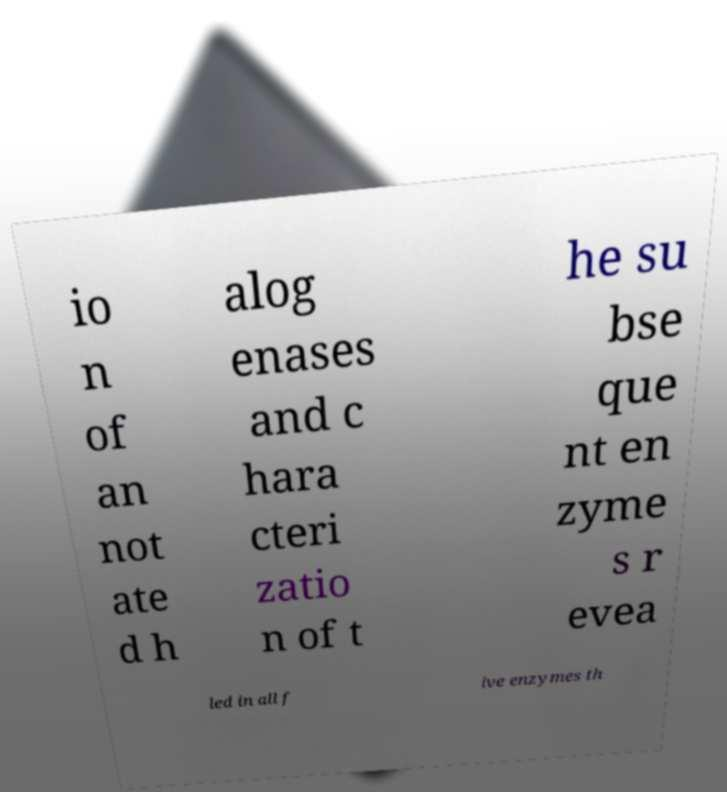I need the written content from this picture converted into text. Can you do that? io n of an not ate d h alog enases and c hara cteri zatio n of t he su bse que nt en zyme s r evea led in all f ive enzymes th 